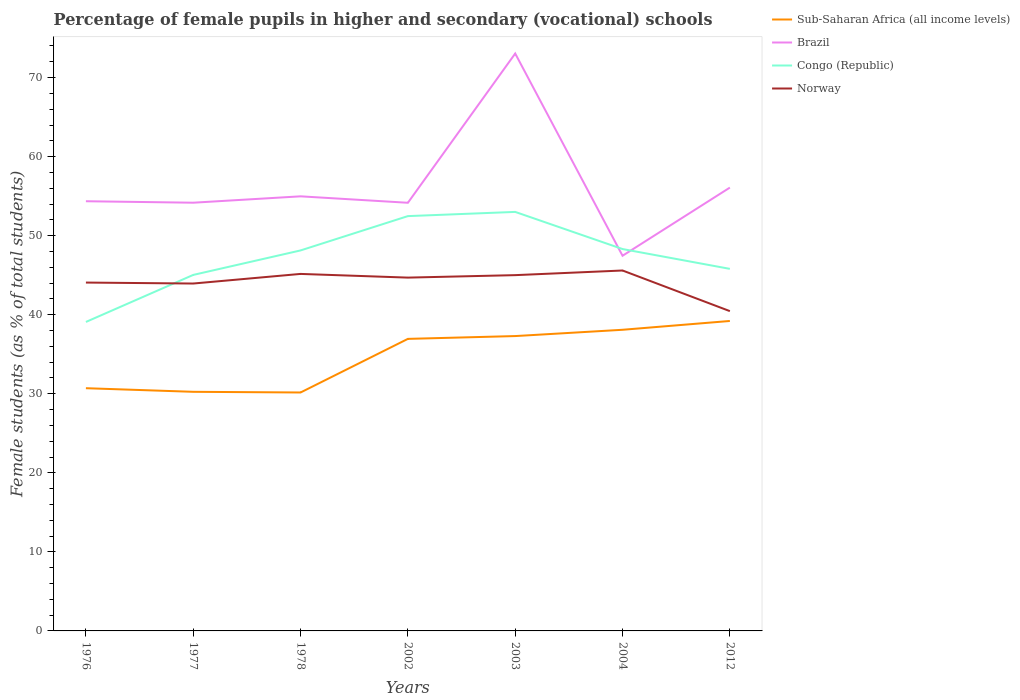Does the line corresponding to Norway intersect with the line corresponding to Congo (Republic)?
Provide a short and direct response. Yes. Is the number of lines equal to the number of legend labels?
Give a very brief answer. Yes. Across all years, what is the maximum percentage of female pupils in higher and secondary schools in Sub-Saharan Africa (all income levels)?
Give a very brief answer. 30.16. In which year was the percentage of female pupils in higher and secondary schools in Brazil maximum?
Your response must be concise. 2004. What is the total percentage of female pupils in higher and secondary schools in Congo (Republic) in the graph?
Give a very brief answer. -4.34. What is the difference between the highest and the second highest percentage of female pupils in higher and secondary schools in Norway?
Provide a short and direct response. 5.14. Is the percentage of female pupils in higher and secondary schools in Norway strictly greater than the percentage of female pupils in higher and secondary schools in Brazil over the years?
Ensure brevity in your answer.  Yes. What is the difference between two consecutive major ticks on the Y-axis?
Provide a short and direct response. 10. Does the graph contain any zero values?
Provide a succinct answer. No. Where does the legend appear in the graph?
Give a very brief answer. Top right. How many legend labels are there?
Offer a very short reply. 4. What is the title of the graph?
Provide a succinct answer. Percentage of female pupils in higher and secondary (vocational) schools. What is the label or title of the X-axis?
Make the answer very short. Years. What is the label or title of the Y-axis?
Offer a very short reply. Female students (as % of total students). What is the Female students (as % of total students) of Sub-Saharan Africa (all income levels) in 1976?
Provide a short and direct response. 30.7. What is the Female students (as % of total students) of Brazil in 1976?
Ensure brevity in your answer.  54.36. What is the Female students (as % of total students) of Congo (Republic) in 1976?
Give a very brief answer. 39.09. What is the Female students (as % of total students) of Norway in 1976?
Give a very brief answer. 44.07. What is the Female students (as % of total students) of Sub-Saharan Africa (all income levels) in 1977?
Ensure brevity in your answer.  30.25. What is the Female students (as % of total students) of Brazil in 1977?
Give a very brief answer. 54.17. What is the Female students (as % of total students) in Congo (Republic) in 1977?
Give a very brief answer. 45.04. What is the Female students (as % of total students) in Norway in 1977?
Your answer should be very brief. 43.95. What is the Female students (as % of total students) of Sub-Saharan Africa (all income levels) in 1978?
Keep it short and to the point. 30.16. What is the Female students (as % of total students) of Brazil in 1978?
Offer a very short reply. 54.98. What is the Female students (as % of total students) of Congo (Republic) in 1978?
Offer a terse response. 48.13. What is the Female students (as % of total students) in Norway in 1978?
Your answer should be compact. 45.16. What is the Female students (as % of total students) in Sub-Saharan Africa (all income levels) in 2002?
Ensure brevity in your answer.  36.94. What is the Female students (as % of total students) of Brazil in 2002?
Provide a short and direct response. 54.16. What is the Female students (as % of total students) of Congo (Republic) in 2002?
Make the answer very short. 52.48. What is the Female students (as % of total students) in Norway in 2002?
Your response must be concise. 44.7. What is the Female students (as % of total students) of Sub-Saharan Africa (all income levels) in 2003?
Offer a very short reply. 37.3. What is the Female students (as % of total students) in Brazil in 2003?
Your answer should be compact. 73.04. What is the Female students (as % of total students) of Congo (Republic) in 2003?
Your answer should be very brief. 53.01. What is the Female students (as % of total students) of Norway in 2003?
Give a very brief answer. 45.01. What is the Female students (as % of total students) in Sub-Saharan Africa (all income levels) in 2004?
Provide a short and direct response. 38.1. What is the Female students (as % of total students) of Brazil in 2004?
Keep it short and to the point. 47.46. What is the Female students (as % of total students) of Congo (Republic) in 2004?
Give a very brief answer. 48.31. What is the Female students (as % of total students) of Norway in 2004?
Provide a short and direct response. 45.6. What is the Female students (as % of total students) of Sub-Saharan Africa (all income levels) in 2012?
Make the answer very short. 39.21. What is the Female students (as % of total students) in Brazil in 2012?
Offer a terse response. 56.08. What is the Female students (as % of total students) of Congo (Republic) in 2012?
Provide a short and direct response. 45.8. What is the Female students (as % of total students) of Norway in 2012?
Give a very brief answer. 40.46. Across all years, what is the maximum Female students (as % of total students) in Sub-Saharan Africa (all income levels)?
Offer a very short reply. 39.21. Across all years, what is the maximum Female students (as % of total students) in Brazil?
Ensure brevity in your answer.  73.04. Across all years, what is the maximum Female students (as % of total students) in Congo (Republic)?
Give a very brief answer. 53.01. Across all years, what is the maximum Female students (as % of total students) in Norway?
Keep it short and to the point. 45.6. Across all years, what is the minimum Female students (as % of total students) of Sub-Saharan Africa (all income levels)?
Ensure brevity in your answer.  30.16. Across all years, what is the minimum Female students (as % of total students) of Brazil?
Ensure brevity in your answer.  47.46. Across all years, what is the minimum Female students (as % of total students) in Congo (Republic)?
Make the answer very short. 39.09. Across all years, what is the minimum Female students (as % of total students) in Norway?
Make the answer very short. 40.46. What is the total Female students (as % of total students) of Sub-Saharan Africa (all income levels) in the graph?
Offer a terse response. 242.67. What is the total Female students (as % of total students) in Brazil in the graph?
Keep it short and to the point. 394.26. What is the total Female students (as % of total students) in Congo (Republic) in the graph?
Your answer should be compact. 331.85. What is the total Female students (as % of total students) of Norway in the graph?
Your response must be concise. 308.93. What is the difference between the Female students (as % of total students) in Sub-Saharan Africa (all income levels) in 1976 and that in 1977?
Provide a short and direct response. 0.46. What is the difference between the Female students (as % of total students) in Brazil in 1976 and that in 1977?
Offer a terse response. 0.19. What is the difference between the Female students (as % of total students) in Congo (Republic) in 1976 and that in 1977?
Your answer should be compact. -5.95. What is the difference between the Female students (as % of total students) of Norway in 1976 and that in 1977?
Give a very brief answer. 0.12. What is the difference between the Female students (as % of total students) in Sub-Saharan Africa (all income levels) in 1976 and that in 1978?
Provide a short and direct response. 0.54. What is the difference between the Female students (as % of total students) in Brazil in 1976 and that in 1978?
Your answer should be compact. -0.62. What is the difference between the Female students (as % of total students) of Congo (Republic) in 1976 and that in 1978?
Ensure brevity in your answer.  -9.05. What is the difference between the Female students (as % of total students) in Norway in 1976 and that in 1978?
Your answer should be compact. -1.09. What is the difference between the Female students (as % of total students) in Sub-Saharan Africa (all income levels) in 1976 and that in 2002?
Your answer should be compact. -6.24. What is the difference between the Female students (as % of total students) in Brazil in 1976 and that in 2002?
Provide a short and direct response. 0.19. What is the difference between the Female students (as % of total students) of Congo (Republic) in 1976 and that in 2002?
Your answer should be compact. -13.39. What is the difference between the Female students (as % of total students) of Norway in 1976 and that in 2002?
Provide a succinct answer. -0.63. What is the difference between the Female students (as % of total students) of Sub-Saharan Africa (all income levels) in 1976 and that in 2003?
Offer a terse response. -6.6. What is the difference between the Female students (as % of total students) in Brazil in 1976 and that in 2003?
Ensure brevity in your answer.  -18.69. What is the difference between the Female students (as % of total students) in Congo (Republic) in 1976 and that in 2003?
Ensure brevity in your answer.  -13.92. What is the difference between the Female students (as % of total students) of Norway in 1976 and that in 2003?
Your answer should be very brief. -0.94. What is the difference between the Female students (as % of total students) of Sub-Saharan Africa (all income levels) in 1976 and that in 2004?
Your answer should be very brief. -7.39. What is the difference between the Female students (as % of total students) of Brazil in 1976 and that in 2004?
Provide a short and direct response. 6.9. What is the difference between the Female students (as % of total students) in Congo (Republic) in 1976 and that in 2004?
Keep it short and to the point. -9.22. What is the difference between the Female students (as % of total students) of Norway in 1976 and that in 2004?
Ensure brevity in your answer.  -1.53. What is the difference between the Female students (as % of total students) of Sub-Saharan Africa (all income levels) in 1976 and that in 2012?
Offer a terse response. -8.51. What is the difference between the Female students (as % of total students) in Brazil in 1976 and that in 2012?
Keep it short and to the point. -1.73. What is the difference between the Female students (as % of total students) of Congo (Republic) in 1976 and that in 2012?
Provide a short and direct response. -6.72. What is the difference between the Female students (as % of total students) of Norway in 1976 and that in 2012?
Your answer should be very brief. 3.61. What is the difference between the Female students (as % of total students) in Sub-Saharan Africa (all income levels) in 1977 and that in 1978?
Make the answer very short. 0.09. What is the difference between the Female students (as % of total students) of Brazil in 1977 and that in 1978?
Provide a short and direct response. -0.81. What is the difference between the Female students (as % of total students) of Congo (Republic) in 1977 and that in 1978?
Give a very brief answer. -3.1. What is the difference between the Female students (as % of total students) of Norway in 1977 and that in 1978?
Offer a very short reply. -1.22. What is the difference between the Female students (as % of total students) of Sub-Saharan Africa (all income levels) in 1977 and that in 2002?
Provide a succinct answer. -6.7. What is the difference between the Female students (as % of total students) in Brazil in 1977 and that in 2002?
Make the answer very short. 0.01. What is the difference between the Female students (as % of total students) in Congo (Republic) in 1977 and that in 2002?
Your response must be concise. -7.44. What is the difference between the Female students (as % of total students) in Norway in 1977 and that in 2002?
Your answer should be compact. -0.75. What is the difference between the Female students (as % of total students) in Sub-Saharan Africa (all income levels) in 1977 and that in 2003?
Provide a succinct answer. -7.05. What is the difference between the Female students (as % of total students) of Brazil in 1977 and that in 2003?
Provide a succinct answer. -18.87. What is the difference between the Female students (as % of total students) of Congo (Republic) in 1977 and that in 2003?
Your answer should be very brief. -7.97. What is the difference between the Female students (as % of total students) of Norway in 1977 and that in 2003?
Make the answer very short. -1.06. What is the difference between the Female students (as % of total students) of Sub-Saharan Africa (all income levels) in 1977 and that in 2004?
Your answer should be very brief. -7.85. What is the difference between the Female students (as % of total students) in Brazil in 1977 and that in 2004?
Your response must be concise. 6.71. What is the difference between the Female students (as % of total students) of Congo (Republic) in 1977 and that in 2004?
Make the answer very short. -3.27. What is the difference between the Female students (as % of total students) of Norway in 1977 and that in 2004?
Provide a succinct answer. -1.65. What is the difference between the Female students (as % of total students) in Sub-Saharan Africa (all income levels) in 1977 and that in 2012?
Provide a succinct answer. -8.96. What is the difference between the Female students (as % of total students) in Brazil in 1977 and that in 2012?
Offer a terse response. -1.91. What is the difference between the Female students (as % of total students) of Congo (Republic) in 1977 and that in 2012?
Ensure brevity in your answer.  -0.77. What is the difference between the Female students (as % of total students) in Norway in 1977 and that in 2012?
Make the answer very short. 3.49. What is the difference between the Female students (as % of total students) in Sub-Saharan Africa (all income levels) in 1978 and that in 2002?
Offer a very short reply. -6.78. What is the difference between the Female students (as % of total students) of Brazil in 1978 and that in 2002?
Provide a succinct answer. 0.82. What is the difference between the Female students (as % of total students) in Congo (Republic) in 1978 and that in 2002?
Your answer should be compact. -4.34. What is the difference between the Female students (as % of total students) of Norway in 1978 and that in 2002?
Your response must be concise. 0.47. What is the difference between the Female students (as % of total students) of Sub-Saharan Africa (all income levels) in 1978 and that in 2003?
Provide a succinct answer. -7.14. What is the difference between the Female students (as % of total students) in Brazil in 1978 and that in 2003?
Offer a very short reply. -18.07. What is the difference between the Female students (as % of total students) in Congo (Republic) in 1978 and that in 2003?
Offer a terse response. -4.87. What is the difference between the Female students (as % of total students) of Norway in 1978 and that in 2003?
Keep it short and to the point. 0.16. What is the difference between the Female students (as % of total students) of Sub-Saharan Africa (all income levels) in 1978 and that in 2004?
Keep it short and to the point. -7.93. What is the difference between the Female students (as % of total students) of Brazil in 1978 and that in 2004?
Provide a short and direct response. 7.52. What is the difference between the Female students (as % of total students) in Congo (Republic) in 1978 and that in 2004?
Make the answer very short. -0.17. What is the difference between the Female students (as % of total students) of Norway in 1978 and that in 2004?
Give a very brief answer. -0.43. What is the difference between the Female students (as % of total students) of Sub-Saharan Africa (all income levels) in 1978 and that in 2012?
Your answer should be very brief. -9.05. What is the difference between the Female students (as % of total students) in Brazil in 1978 and that in 2012?
Make the answer very short. -1.11. What is the difference between the Female students (as % of total students) of Congo (Republic) in 1978 and that in 2012?
Your response must be concise. 2.33. What is the difference between the Female students (as % of total students) of Norway in 1978 and that in 2012?
Provide a succinct answer. 4.71. What is the difference between the Female students (as % of total students) in Sub-Saharan Africa (all income levels) in 2002 and that in 2003?
Offer a very short reply. -0.36. What is the difference between the Female students (as % of total students) of Brazil in 2002 and that in 2003?
Make the answer very short. -18.88. What is the difference between the Female students (as % of total students) in Congo (Republic) in 2002 and that in 2003?
Make the answer very short. -0.53. What is the difference between the Female students (as % of total students) of Norway in 2002 and that in 2003?
Your answer should be compact. -0.31. What is the difference between the Female students (as % of total students) in Sub-Saharan Africa (all income levels) in 2002 and that in 2004?
Keep it short and to the point. -1.15. What is the difference between the Female students (as % of total students) in Brazil in 2002 and that in 2004?
Make the answer very short. 6.7. What is the difference between the Female students (as % of total students) in Congo (Republic) in 2002 and that in 2004?
Provide a short and direct response. 4.17. What is the difference between the Female students (as % of total students) of Norway in 2002 and that in 2004?
Ensure brevity in your answer.  -0.9. What is the difference between the Female students (as % of total students) in Sub-Saharan Africa (all income levels) in 2002 and that in 2012?
Your answer should be compact. -2.27. What is the difference between the Female students (as % of total students) of Brazil in 2002 and that in 2012?
Offer a very short reply. -1.92. What is the difference between the Female students (as % of total students) in Congo (Republic) in 2002 and that in 2012?
Offer a terse response. 6.67. What is the difference between the Female students (as % of total students) in Norway in 2002 and that in 2012?
Provide a short and direct response. 4.24. What is the difference between the Female students (as % of total students) in Sub-Saharan Africa (all income levels) in 2003 and that in 2004?
Provide a succinct answer. -0.8. What is the difference between the Female students (as % of total students) of Brazil in 2003 and that in 2004?
Your response must be concise. 25.58. What is the difference between the Female students (as % of total students) in Congo (Republic) in 2003 and that in 2004?
Provide a succinct answer. 4.7. What is the difference between the Female students (as % of total students) in Norway in 2003 and that in 2004?
Your response must be concise. -0.59. What is the difference between the Female students (as % of total students) of Sub-Saharan Africa (all income levels) in 2003 and that in 2012?
Ensure brevity in your answer.  -1.91. What is the difference between the Female students (as % of total students) of Brazil in 2003 and that in 2012?
Ensure brevity in your answer.  16.96. What is the difference between the Female students (as % of total students) in Congo (Republic) in 2003 and that in 2012?
Make the answer very short. 7.2. What is the difference between the Female students (as % of total students) in Norway in 2003 and that in 2012?
Your answer should be compact. 4.55. What is the difference between the Female students (as % of total students) of Sub-Saharan Africa (all income levels) in 2004 and that in 2012?
Your answer should be very brief. -1.12. What is the difference between the Female students (as % of total students) of Brazil in 2004 and that in 2012?
Provide a succinct answer. -8.62. What is the difference between the Female students (as % of total students) of Congo (Republic) in 2004 and that in 2012?
Make the answer very short. 2.51. What is the difference between the Female students (as % of total students) of Norway in 2004 and that in 2012?
Provide a succinct answer. 5.14. What is the difference between the Female students (as % of total students) in Sub-Saharan Africa (all income levels) in 1976 and the Female students (as % of total students) in Brazil in 1977?
Provide a short and direct response. -23.47. What is the difference between the Female students (as % of total students) in Sub-Saharan Africa (all income levels) in 1976 and the Female students (as % of total students) in Congo (Republic) in 1977?
Give a very brief answer. -14.33. What is the difference between the Female students (as % of total students) in Sub-Saharan Africa (all income levels) in 1976 and the Female students (as % of total students) in Norway in 1977?
Make the answer very short. -13.24. What is the difference between the Female students (as % of total students) of Brazil in 1976 and the Female students (as % of total students) of Congo (Republic) in 1977?
Keep it short and to the point. 9.32. What is the difference between the Female students (as % of total students) in Brazil in 1976 and the Female students (as % of total students) in Norway in 1977?
Provide a short and direct response. 10.41. What is the difference between the Female students (as % of total students) in Congo (Republic) in 1976 and the Female students (as % of total students) in Norway in 1977?
Your answer should be compact. -4.86. What is the difference between the Female students (as % of total students) in Sub-Saharan Africa (all income levels) in 1976 and the Female students (as % of total students) in Brazil in 1978?
Make the answer very short. -24.27. What is the difference between the Female students (as % of total students) of Sub-Saharan Africa (all income levels) in 1976 and the Female students (as % of total students) of Congo (Republic) in 1978?
Ensure brevity in your answer.  -17.43. What is the difference between the Female students (as % of total students) in Sub-Saharan Africa (all income levels) in 1976 and the Female students (as % of total students) in Norway in 1978?
Your answer should be very brief. -14.46. What is the difference between the Female students (as % of total students) in Brazil in 1976 and the Female students (as % of total students) in Congo (Republic) in 1978?
Make the answer very short. 6.22. What is the difference between the Female students (as % of total students) in Brazil in 1976 and the Female students (as % of total students) in Norway in 1978?
Keep it short and to the point. 9.19. What is the difference between the Female students (as % of total students) in Congo (Republic) in 1976 and the Female students (as % of total students) in Norway in 1978?
Give a very brief answer. -6.08. What is the difference between the Female students (as % of total students) in Sub-Saharan Africa (all income levels) in 1976 and the Female students (as % of total students) in Brazil in 2002?
Give a very brief answer. -23.46. What is the difference between the Female students (as % of total students) of Sub-Saharan Africa (all income levels) in 1976 and the Female students (as % of total students) of Congo (Republic) in 2002?
Your answer should be compact. -21.77. What is the difference between the Female students (as % of total students) in Sub-Saharan Africa (all income levels) in 1976 and the Female students (as % of total students) in Norway in 2002?
Ensure brevity in your answer.  -13.99. What is the difference between the Female students (as % of total students) in Brazil in 1976 and the Female students (as % of total students) in Congo (Republic) in 2002?
Keep it short and to the point. 1.88. What is the difference between the Female students (as % of total students) of Brazil in 1976 and the Female students (as % of total students) of Norway in 2002?
Provide a short and direct response. 9.66. What is the difference between the Female students (as % of total students) in Congo (Republic) in 1976 and the Female students (as % of total students) in Norway in 2002?
Offer a very short reply. -5.61. What is the difference between the Female students (as % of total students) of Sub-Saharan Africa (all income levels) in 1976 and the Female students (as % of total students) of Brazil in 2003?
Offer a terse response. -42.34. What is the difference between the Female students (as % of total students) of Sub-Saharan Africa (all income levels) in 1976 and the Female students (as % of total students) of Congo (Republic) in 2003?
Ensure brevity in your answer.  -22.3. What is the difference between the Female students (as % of total students) in Sub-Saharan Africa (all income levels) in 1976 and the Female students (as % of total students) in Norway in 2003?
Offer a very short reply. -14.3. What is the difference between the Female students (as % of total students) in Brazil in 1976 and the Female students (as % of total students) in Congo (Republic) in 2003?
Your response must be concise. 1.35. What is the difference between the Female students (as % of total students) in Brazil in 1976 and the Female students (as % of total students) in Norway in 2003?
Keep it short and to the point. 9.35. What is the difference between the Female students (as % of total students) in Congo (Republic) in 1976 and the Female students (as % of total students) in Norway in 2003?
Your answer should be very brief. -5.92. What is the difference between the Female students (as % of total students) in Sub-Saharan Africa (all income levels) in 1976 and the Female students (as % of total students) in Brazil in 2004?
Ensure brevity in your answer.  -16.76. What is the difference between the Female students (as % of total students) of Sub-Saharan Africa (all income levels) in 1976 and the Female students (as % of total students) of Congo (Republic) in 2004?
Offer a terse response. -17.6. What is the difference between the Female students (as % of total students) of Sub-Saharan Africa (all income levels) in 1976 and the Female students (as % of total students) of Norway in 2004?
Give a very brief answer. -14.89. What is the difference between the Female students (as % of total students) of Brazil in 1976 and the Female students (as % of total students) of Congo (Republic) in 2004?
Provide a succinct answer. 6.05. What is the difference between the Female students (as % of total students) in Brazil in 1976 and the Female students (as % of total students) in Norway in 2004?
Your response must be concise. 8.76. What is the difference between the Female students (as % of total students) of Congo (Republic) in 1976 and the Female students (as % of total students) of Norway in 2004?
Your answer should be compact. -6.51. What is the difference between the Female students (as % of total students) of Sub-Saharan Africa (all income levels) in 1976 and the Female students (as % of total students) of Brazil in 2012?
Offer a terse response. -25.38. What is the difference between the Female students (as % of total students) in Sub-Saharan Africa (all income levels) in 1976 and the Female students (as % of total students) in Congo (Republic) in 2012?
Offer a terse response. -15.1. What is the difference between the Female students (as % of total students) of Sub-Saharan Africa (all income levels) in 1976 and the Female students (as % of total students) of Norway in 2012?
Provide a short and direct response. -9.75. What is the difference between the Female students (as % of total students) in Brazil in 1976 and the Female students (as % of total students) in Congo (Republic) in 2012?
Provide a succinct answer. 8.55. What is the difference between the Female students (as % of total students) of Brazil in 1976 and the Female students (as % of total students) of Norway in 2012?
Your answer should be very brief. 13.9. What is the difference between the Female students (as % of total students) in Congo (Republic) in 1976 and the Female students (as % of total students) in Norway in 2012?
Make the answer very short. -1.37. What is the difference between the Female students (as % of total students) in Sub-Saharan Africa (all income levels) in 1977 and the Female students (as % of total students) in Brazil in 1978?
Ensure brevity in your answer.  -24.73. What is the difference between the Female students (as % of total students) of Sub-Saharan Africa (all income levels) in 1977 and the Female students (as % of total students) of Congo (Republic) in 1978?
Make the answer very short. -17.89. What is the difference between the Female students (as % of total students) of Sub-Saharan Africa (all income levels) in 1977 and the Female students (as % of total students) of Norway in 1978?
Offer a terse response. -14.91. What is the difference between the Female students (as % of total students) in Brazil in 1977 and the Female students (as % of total students) in Congo (Republic) in 1978?
Offer a very short reply. 6.04. What is the difference between the Female students (as % of total students) of Brazil in 1977 and the Female students (as % of total students) of Norway in 1978?
Provide a short and direct response. 9.01. What is the difference between the Female students (as % of total students) in Congo (Republic) in 1977 and the Female students (as % of total students) in Norway in 1978?
Ensure brevity in your answer.  -0.13. What is the difference between the Female students (as % of total students) in Sub-Saharan Africa (all income levels) in 1977 and the Female students (as % of total students) in Brazil in 2002?
Keep it short and to the point. -23.91. What is the difference between the Female students (as % of total students) in Sub-Saharan Africa (all income levels) in 1977 and the Female students (as % of total students) in Congo (Republic) in 2002?
Keep it short and to the point. -22.23. What is the difference between the Female students (as % of total students) of Sub-Saharan Africa (all income levels) in 1977 and the Female students (as % of total students) of Norway in 2002?
Ensure brevity in your answer.  -14.45. What is the difference between the Female students (as % of total students) in Brazil in 1977 and the Female students (as % of total students) in Congo (Republic) in 2002?
Your answer should be compact. 1.7. What is the difference between the Female students (as % of total students) of Brazil in 1977 and the Female students (as % of total students) of Norway in 2002?
Provide a succinct answer. 9.48. What is the difference between the Female students (as % of total students) in Congo (Republic) in 1977 and the Female students (as % of total students) in Norway in 2002?
Your response must be concise. 0.34. What is the difference between the Female students (as % of total students) of Sub-Saharan Africa (all income levels) in 1977 and the Female students (as % of total students) of Brazil in 2003?
Provide a short and direct response. -42.8. What is the difference between the Female students (as % of total students) in Sub-Saharan Africa (all income levels) in 1977 and the Female students (as % of total students) in Congo (Republic) in 2003?
Give a very brief answer. -22.76. What is the difference between the Female students (as % of total students) in Sub-Saharan Africa (all income levels) in 1977 and the Female students (as % of total students) in Norway in 2003?
Your answer should be compact. -14.76. What is the difference between the Female students (as % of total students) of Brazil in 1977 and the Female students (as % of total students) of Congo (Republic) in 2003?
Your answer should be compact. 1.17. What is the difference between the Female students (as % of total students) in Brazil in 1977 and the Female students (as % of total students) in Norway in 2003?
Keep it short and to the point. 9.16. What is the difference between the Female students (as % of total students) of Congo (Republic) in 1977 and the Female students (as % of total students) of Norway in 2003?
Keep it short and to the point. 0.03. What is the difference between the Female students (as % of total students) in Sub-Saharan Africa (all income levels) in 1977 and the Female students (as % of total students) in Brazil in 2004?
Your response must be concise. -17.21. What is the difference between the Female students (as % of total students) of Sub-Saharan Africa (all income levels) in 1977 and the Female students (as % of total students) of Congo (Republic) in 2004?
Offer a terse response. -18.06. What is the difference between the Female students (as % of total students) of Sub-Saharan Africa (all income levels) in 1977 and the Female students (as % of total students) of Norway in 2004?
Your answer should be very brief. -15.35. What is the difference between the Female students (as % of total students) of Brazil in 1977 and the Female students (as % of total students) of Congo (Republic) in 2004?
Give a very brief answer. 5.86. What is the difference between the Female students (as % of total students) of Brazil in 1977 and the Female students (as % of total students) of Norway in 2004?
Your answer should be compact. 8.58. What is the difference between the Female students (as % of total students) in Congo (Republic) in 1977 and the Female students (as % of total students) in Norway in 2004?
Offer a very short reply. -0.56. What is the difference between the Female students (as % of total students) of Sub-Saharan Africa (all income levels) in 1977 and the Female students (as % of total students) of Brazil in 2012?
Your response must be concise. -25.84. What is the difference between the Female students (as % of total students) of Sub-Saharan Africa (all income levels) in 1977 and the Female students (as % of total students) of Congo (Republic) in 2012?
Your answer should be very brief. -15.56. What is the difference between the Female students (as % of total students) in Sub-Saharan Africa (all income levels) in 1977 and the Female students (as % of total students) in Norway in 2012?
Give a very brief answer. -10.21. What is the difference between the Female students (as % of total students) of Brazil in 1977 and the Female students (as % of total students) of Congo (Republic) in 2012?
Give a very brief answer. 8.37. What is the difference between the Female students (as % of total students) of Brazil in 1977 and the Female students (as % of total students) of Norway in 2012?
Provide a succinct answer. 13.72. What is the difference between the Female students (as % of total students) in Congo (Republic) in 1977 and the Female students (as % of total students) in Norway in 2012?
Offer a very short reply. 4.58. What is the difference between the Female students (as % of total students) of Sub-Saharan Africa (all income levels) in 1978 and the Female students (as % of total students) of Brazil in 2002?
Give a very brief answer. -24. What is the difference between the Female students (as % of total students) in Sub-Saharan Africa (all income levels) in 1978 and the Female students (as % of total students) in Congo (Republic) in 2002?
Your answer should be very brief. -22.31. What is the difference between the Female students (as % of total students) of Sub-Saharan Africa (all income levels) in 1978 and the Female students (as % of total students) of Norway in 2002?
Offer a very short reply. -14.53. What is the difference between the Female students (as % of total students) in Brazil in 1978 and the Female students (as % of total students) in Congo (Republic) in 2002?
Give a very brief answer. 2.5. What is the difference between the Female students (as % of total students) of Brazil in 1978 and the Female students (as % of total students) of Norway in 2002?
Your answer should be very brief. 10.28. What is the difference between the Female students (as % of total students) in Congo (Republic) in 1978 and the Female students (as % of total students) in Norway in 2002?
Give a very brief answer. 3.44. What is the difference between the Female students (as % of total students) in Sub-Saharan Africa (all income levels) in 1978 and the Female students (as % of total students) in Brazil in 2003?
Keep it short and to the point. -42.88. What is the difference between the Female students (as % of total students) of Sub-Saharan Africa (all income levels) in 1978 and the Female students (as % of total students) of Congo (Republic) in 2003?
Make the answer very short. -22.84. What is the difference between the Female students (as % of total students) in Sub-Saharan Africa (all income levels) in 1978 and the Female students (as % of total students) in Norway in 2003?
Offer a very short reply. -14.84. What is the difference between the Female students (as % of total students) in Brazil in 1978 and the Female students (as % of total students) in Congo (Republic) in 2003?
Give a very brief answer. 1.97. What is the difference between the Female students (as % of total students) of Brazil in 1978 and the Female students (as % of total students) of Norway in 2003?
Provide a succinct answer. 9.97. What is the difference between the Female students (as % of total students) in Congo (Republic) in 1978 and the Female students (as % of total students) in Norway in 2003?
Your answer should be compact. 3.13. What is the difference between the Female students (as % of total students) of Sub-Saharan Africa (all income levels) in 1978 and the Female students (as % of total students) of Brazil in 2004?
Offer a very short reply. -17.3. What is the difference between the Female students (as % of total students) in Sub-Saharan Africa (all income levels) in 1978 and the Female students (as % of total students) in Congo (Republic) in 2004?
Keep it short and to the point. -18.15. What is the difference between the Female students (as % of total students) in Sub-Saharan Africa (all income levels) in 1978 and the Female students (as % of total students) in Norway in 2004?
Your answer should be very brief. -15.43. What is the difference between the Female students (as % of total students) in Brazil in 1978 and the Female students (as % of total students) in Congo (Republic) in 2004?
Offer a terse response. 6.67. What is the difference between the Female students (as % of total students) in Brazil in 1978 and the Female students (as % of total students) in Norway in 2004?
Make the answer very short. 9.38. What is the difference between the Female students (as % of total students) of Congo (Republic) in 1978 and the Female students (as % of total students) of Norway in 2004?
Provide a short and direct response. 2.54. What is the difference between the Female students (as % of total students) in Sub-Saharan Africa (all income levels) in 1978 and the Female students (as % of total students) in Brazil in 2012?
Ensure brevity in your answer.  -25.92. What is the difference between the Female students (as % of total students) of Sub-Saharan Africa (all income levels) in 1978 and the Female students (as % of total students) of Congo (Republic) in 2012?
Your response must be concise. -15.64. What is the difference between the Female students (as % of total students) in Sub-Saharan Africa (all income levels) in 1978 and the Female students (as % of total students) in Norway in 2012?
Your answer should be compact. -10.29. What is the difference between the Female students (as % of total students) of Brazil in 1978 and the Female students (as % of total students) of Congo (Republic) in 2012?
Your answer should be compact. 9.17. What is the difference between the Female students (as % of total students) in Brazil in 1978 and the Female students (as % of total students) in Norway in 2012?
Your response must be concise. 14.52. What is the difference between the Female students (as % of total students) in Congo (Republic) in 1978 and the Female students (as % of total students) in Norway in 2012?
Your response must be concise. 7.68. What is the difference between the Female students (as % of total students) of Sub-Saharan Africa (all income levels) in 2002 and the Female students (as % of total students) of Brazil in 2003?
Provide a succinct answer. -36.1. What is the difference between the Female students (as % of total students) in Sub-Saharan Africa (all income levels) in 2002 and the Female students (as % of total students) in Congo (Republic) in 2003?
Give a very brief answer. -16.06. What is the difference between the Female students (as % of total students) of Sub-Saharan Africa (all income levels) in 2002 and the Female students (as % of total students) of Norway in 2003?
Provide a succinct answer. -8.06. What is the difference between the Female students (as % of total students) of Brazil in 2002 and the Female students (as % of total students) of Congo (Republic) in 2003?
Your answer should be compact. 1.16. What is the difference between the Female students (as % of total students) in Brazil in 2002 and the Female students (as % of total students) in Norway in 2003?
Offer a terse response. 9.16. What is the difference between the Female students (as % of total students) of Congo (Republic) in 2002 and the Female students (as % of total students) of Norway in 2003?
Your answer should be very brief. 7.47. What is the difference between the Female students (as % of total students) of Sub-Saharan Africa (all income levels) in 2002 and the Female students (as % of total students) of Brazil in 2004?
Provide a short and direct response. -10.52. What is the difference between the Female students (as % of total students) of Sub-Saharan Africa (all income levels) in 2002 and the Female students (as % of total students) of Congo (Republic) in 2004?
Your answer should be compact. -11.36. What is the difference between the Female students (as % of total students) of Sub-Saharan Africa (all income levels) in 2002 and the Female students (as % of total students) of Norway in 2004?
Make the answer very short. -8.65. What is the difference between the Female students (as % of total students) in Brazil in 2002 and the Female students (as % of total students) in Congo (Republic) in 2004?
Your response must be concise. 5.85. What is the difference between the Female students (as % of total students) in Brazil in 2002 and the Female students (as % of total students) in Norway in 2004?
Give a very brief answer. 8.57. What is the difference between the Female students (as % of total students) in Congo (Republic) in 2002 and the Female students (as % of total students) in Norway in 2004?
Offer a very short reply. 6.88. What is the difference between the Female students (as % of total students) of Sub-Saharan Africa (all income levels) in 2002 and the Female students (as % of total students) of Brazil in 2012?
Offer a very short reply. -19.14. What is the difference between the Female students (as % of total students) in Sub-Saharan Africa (all income levels) in 2002 and the Female students (as % of total students) in Congo (Republic) in 2012?
Keep it short and to the point. -8.86. What is the difference between the Female students (as % of total students) of Sub-Saharan Africa (all income levels) in 2002 and the Female students (as % of total students) of Norway in 2012?
Give a very brief answer. -3.51. What is the difference between the Female students (as % of total students) of Brazil in 2002 and the Female students (as % of total students) of Congo (Republic) in 2012?
Your answer should be compact. 8.36. What is the difference between the Female students (as % of total students) of Brazil in 2002 and the Female students (as % of total students) of Norway in 2012?
Offer a terse response. 13.71. What is the difference between the Female students (as % of total students) of Congo (Republic) in 2002 and the Female students (as % of total students) of Norway in 2012?
Offer a very short reply. 12.02. What is the difference between the Female students (as % of total students) of Sub-Saharan Africa (all income levels) in 2003 and the Female students (as % of total students) of Brazil in 2004?
Your answer should be compact. -10.16. What is the difference between the Female students (as % of total students) in Sub-Saharan Africa (all income levels) in 2003 and the Female students (as % of total students) in Congo (Republic) in 2004?
Ensure brevity in your answer.  -11.01. What is the difference between the Female students (as % of total students) of Sub-Saharan Africa (all income levels) in 2003 and the Female students (as % of total students) of Norway in 2004?
Your response must be concise. -8.3. What is the difference between the Female students (as % of total students) of Brazil in 2003 and the Female students (as % of total students) of Congo (Republic) in 2004?
Give a very brief answer. 24.73. What is the difference between the Female students (as % of total students) of Brazil in 2003 and the Female students (as % of total students) of Norway in 2004?
Keep it short and to the point. 27.45. What is the difference between the Female students (as % of total students) of Congo (Republic) in 2003 and the Female students (as % of total students) of Norway in 2004?
Your answer should be very brief. 7.41. What is the difference between the Female students (as % of total students) in Sub-Saharan Africa (all income levels) in 2003 and the Female students (as % of total students) in Brazil in 2012?
Ensure brevity in your answer.  -18.78. What is the difference between the Female students (as % of total students) of Sub-Saharan Africa (all income levels) in 2003 and the Female students (as % of total students) of Congo (Republic) in 2012?
Give a very brief answer. -8.5. What is the difference between the Female students (as % of total students) of Sub-Saharan Africa (all income levels) in 2003 and the Female students (as % of total students) of Norway in 2012?
Provide a succinct answer. -3.16. What is the difference between the Female students (as % of total students) in Brazil in 2003 and the Female students (as % of total students) in Congo (Republic) in 2012?
Keep it short and to the point. 27.24. What is the difference between the Female students (as % of total students) of Brazil in 2003 and the Female students (as % of total students) of Norway in 2012?
Offer a very short reply. 32.59. What is the difference between the Female students (as % of total students) in Congo (Republic) in 2003 and the Female students (as % of total students) in Norway in 2012?
Offer a terse response. 12.55. What is the difference between the Female students (as % of total students) of Sub-Saharan Africa (all income levels) in 2004 and the Female students (as % of total students) of Brazil in 2012?
Make the answer very short. -17.99. What is the difference between the Female students (as % of total students) in Sub-Saharan Africa (all income levels) in 2004 and the Female students (as % of total students) in Congo (Republic) in 2012?
Offer a terse response. -7.71. What is the difference between the Female students (as % of total students) in Sub-Saharan Africa (all income levels) in 2004 and the Female students (as % of total students) in Norway in 2012?
Your answer should be very brief. -2.36. What is the difference between the Female students (as % of total students) in Brazil in 2004 and the Female students (as % of total students) in Congo (Republic) in 2012?
Give a very brief answer. 1.66. What is the difference between the Female students (as % of total students) in Brazil in 2004 and the Female students (as % of total students) in Norway in 2012?
Your answer should be compact. 7. What is the difference between the Female students (as % of total students) of Congo (Republic) in 2004 and the Female students (as % of total students) of Norway in 2012?
Your answer should be very brief. 7.85. What is the average Female students (as % of total students) of Sub-Saharan Africa (all income levels) per year?
Your answer should be compact. 34.67. What is the average Female students (as % of total students) in Brazil per year?
Your response must be concise. 56.32. What is the average Female students (as % of total students) in Congo (Republic) per year?
Offer a very short reply. 47.41. What is the average Female students (as % of total students) of Norway per year?
Your answer should be very brief. 44.13. In the year 1976, what is the difference between the Female students (as % of total students) of Sub-Saharan Africa (all income levels) and Female students (as % of total students) of Brazil?
Your response must be concise. -23.65. In the year 1976, what is the difference between the Female students (as % of total students) of Sub-Saharan Africa (all income levels) and Female students (as % of total students) of Congo (Republic)?
Provide a succinct answer. -8.38. In the year 1976, what is the difference between the Female students (as % of total students) in Sub-Saharan Africa (all income levels) and Female students (as % of total students) in Norway?
Keep it short and to the point. -13.36. In the year 1976, what is the difference between the Female students (as % of total students) of Brazil and Female students (as % of total students) of Congo (Republic)?
Your response must be concise. 15.27. In the year 1976, what is the difference between the Female students (as % of total students) of Brazil and Female students (as % of total students) of Norway?
Your answer should be compact. 10.29. In the year 1976, what is the difference between the Female students (as % of total students) in Congo (Republic) and Female students (as % of total students) in Norway?
Ensure brevity in your answer.  -4.98. In the year 1977, what is the difference between the Female students (as % of total students) of Sub-Saharan Africa (all income levels) and Female students (as % of total students) of Brazil?
Provide a short and direct response. -23.92. In the year 1977, what is the difference between the Female students (as % of total students) of Sub-Saharan Africa (all income levels) and Female students (as % of total students) of Congo (Republic)?
Ensure brevity in your answer.  -14.79. In the year 1977, what is the difference between the Female students (as % of total students) of Sub-Saharan Africa (all income levels) and Female students (as % of total students) of Norway?
Keep it short and to the point. -13.7. In the year 1977, what is the difference between the Female students (as % of total students) of Brazil and Female students (as % of total students) of Congo (Republic)?
Offer a terse response. 9.14. In the year 1977, what is the difference between the Female students (as % of total students) of Brazil and Female students (as % of total students) of Norway?
Your answer should be compact. 10.23. In the year 1977, what is the difference between the Female students (as % of total students) of Congo (Republic) and Female students (as % of total students) of Norway?
Provide a short and direct response. 1.09. In the year 1978, what is the difference between the Female students (as % of total students) of Sub-Saharan Africa (all income levels) and Female students (as % of total students) of Brazil?
Keep it short and to the point. -24.82. In the year 1978, what is the difference between the Female students (as % of total students) in Sub-Saharan Africa (all income levels) and Female students (as % of total students) in Congo (Republic)?
Make the answer very short. -17.97. In the year 1978, what is the difference between the Female students (as % of total students) of Sub-Saharan Africa (all income levels) and Female students (as % of total students) of Norway?
Offer a terse response. -15. In the year 1978, what is the difference between the Female students (as % of total students) in Brazil and Female students (as % of total students) in Congo (Republic)?
Provide a short and direct response. 6.84. In the year 1978, what is the difference between the Female students (as % of total students) of Brazil and Female students (as % of total students) of Norway?
Your answer should be compact. 9.82. In the year 1978, what is the difference between the Female students (as % of total students) of Congo (Republic) and Female students (as % of total students) of Norway?
Provide a short and direct response. 2.97. In the year 2002, what is the difference between the Female students (as % of total students) in Sub-Saharan Africa (all income levels) and Female students (as % of total students) in Brazil?
Offer a very short reply. -17.22. In the year 2002, what is the difference between the Female students (as % of total students) of Sub-Saharan Africa (all income levels) and Female students (as % of total students) of Congo (Republic)?
Offer a very short reply. -15.53. In the year 2002, what is the difference between the Female students (as % of total students) in Sub-Saharan Africa (all income levels) and Female students (as % of total students) in Norway?
Provide a succinct answer. -7.75. In the year 2002, what is the difference between the Female students (as % of total students) in Brazil and Female students (as % of total students) in Congo (Republic)?
Make the answer very short. 1.69. In the year 2002, what is the difference between the Female students (as % of total students) in Brazil and Female students (as % of total students) in Norway?
Your answer should be very brief. 9.47. In the year 2002, what is the difference between the Female students (as % of total students) in Congo (Republic) and Female students (as % of total students) in Norway?
Ensure brevity in your answer.  7.78. In the year 2003, what is the difference between the Female students (as % of total students) in Sub-Saharan Africa (all income levels) and Female students (as % of total students) in Brazil?
Offer a terse response. -35.74. In the year 2003, what is the difference between the Female students (as % of total students) in Sub-Saharan Africa (all income levels) and Female students (as % of total students) in Congo (Republic)?
Keep it short and to the point. -15.71. In the year 2003, what is the difference between the Female students (as % of total students) of Sub-Saharan Africa (all income levels) and Female students (as % of total students) of Norway?
Provide a succinct answer. -7.71. In the year 2003, what is the difference between the Female students (as % of total students) in Brazil and Female students (as % of total students) in Congo (Republic)?
Ensure brevity in your answer.  20.04. In the year 2003, what is the difference between the Female students (as % of total students) of Brazil and Female students (as % of total students) of Norway?
Your response must be concise. 28.04. In the year 2003, what is the difference between the Female students (as % of total students) of Congo (Republic) and Female students (as % of total students) of Norway?
Provide a short and direct response. 8. In the year 2004, what is the difference between the Female students (as % of total students) in Sub-Saharan Africa (all income levels) and Female students (as % of total students) in Brazil?
Your response must be concise. -9.36. In the year 2004, what is the difference between the Female students (as % of total students) of Sub-Saharan Africa (all income levels) and Female students (as % of total students) of Congo (Republic)?
Give a very brief answer. -10.21. In the year 2004, what is the difference between the Female students (as % of total students) in Sub-Saharan Africa (all income levels) and Female students (as % of total students) in Norway?
Provide a short and direct response. -7.5. In the year 2004, what is the difference between the Female students (as % of total students) in Brazil and Female students (as % of total students) in Congo (Republic)?
Ensure brevity in your answer.  -0.85. In the year 2004, what is the difference between the Female students (as % of total students) in Brazil and Female students (as % of total students) in Norway?
Make the answer very short. 1.86. In the year 2004, what is the difference between the Female students (as % of total students) of Congo (Republic) and Female students (as % of total students) of Norway?
Provide a short and direct response. 2.71. In the year 2012, what is the difference between the Female students (as % of total students) in Sub-Saharan Africa (all income levels) and Female students (as % of total students) in Brazil?
Keep it short and to the point. -16.87. In the year 2012, what is the difference between the Female students (as % of total students) in Sub-Saharan Africa (all income levels) and Female students (as % of total students) in Congo (Republic)?
Provide a succinct answer. -6.59. In the year 2012, what is the difference between the Female students (as % of total students) in Sub-Saharan Africa (all income levels) and Female students (as % of total students) in Norway?
Your response must be concise. -1.24. In the year 2012, what is the difference between the Female students (as % of total students) in Brazil and Female students (as % of total students) in Congo (Republic)?
Give a very brief answer. 10.28. In the year 2012, what is the difference between the Female students (as % of total students) of Brazil and Female students (as % of total students) of Norway?
Provide a short and direct response. 15.63. In the year 2012, what is the difference between the Female students (as % of total students) of Congo (Republic) and Female students (as % of total students) of Norway?
Offer a very short reply. 5.35. What is the ratio of the Female students (as % of total students) of Sub-Saharan Africa (all income levels) in 1976 to that in 1977?
Your answer should be very brief. 1.02. What is the ratio of the Female students (as % of total students) of Brazil in 1976 to that in 1977?
Offer a terse response. 1. What is the ratio of the Female students (as % of total students) of Congo (Republic) in 1976 to that in 1977?
Provide a short and direct response. 0.87. What is the ratio of the Female students (as % of total students) of Sub-Saharan Africa (all income levels) in 1976 to that in 1978?
Your response must be concise. 1.02. What is the ratio of the Female students (as % of total students) of Brazil in 1976 to that in 1978?
Ensure brevity in your answer.  0.99. What is the ratio of the Female students (as % of total students) in Congo (Republic) in 1976 to that in 1978?
Your response must be concise. 0.81. What is the ratio of the Female students (as % of total students) of Norway in 1976 to that in 1978?
Offer a terse response. 0.98. What is the ratio of the Female students (as % of total students) in Sub-Saharan Africa (all income levels) in 1976 to that in 2002?
Offer a very short reply. 0.83. What is the ratio of the Female students (as % of total students) of Congo (Republic) in 1976 to that in 2002?
Ensure brevity in your answer.  0.74. What is the ratio of the Female students (as % of total students) in Sub-Saharan Africa (all income levels) in 1976 to that in 2003?
Provide a short and direct response. 0.82. What is the ratio of the Female students (as % of total students) of Brazil in 1976 to that in 2003?
Your answer should be very brief. 0.74. What is the ratio of the Female students (as % of total students) of Congo (Republic) in 1976 to that in 2003?
Your answer should be very brief. 0.74. What is the ratio of the Female students (as % of total students) in Norway in 1976 to that in 2003?
Provide a succinct answer. 0.98. What is the ratio of the Female students (as % of total students) in Sub-Saharan Africa (all income levels) in 1976 to that in 2004?
Your answer should be compact. 0.81. What is the ratio of the Female students (as % of total students) in Brazil in 1976 to that in 2004?
Ensure brevity in your answer.  1.15. What is the ratio of the Female students (as % of total students) of Congo (Republic) in 1976 to that in 2004?
Provide a short and direct response. 0.81. What is the ratio of the Female students (as % of total students) in Norway in 1976 to that in 2004?
Make the answer very short. 0.97. What is the ratio of the Female students (as % of total students) of Sub-Saharan Africa (all income levels) in 1976 to that in 2012?
Your answer should be very brief. 0.78. What is the ratio of the Female students (as % of total students) in Brazil in 1976 to that in 2012?
Provide a short and direct response. 0.97. What is the ratio of the Female students (as % of total students) in Congo (Republic) in 1976 to that in 2012?
Your answer should be compact. 0.85. What is the ratio of the Female students (as % of total students) in Norway in 1976 to that in 2012?
Your answer should be very brief. 1.09. What is the ratio of the Female students (as % of total students) of Congo (Republic) in 1977 to that in 1978?
Offer a terse response. 0.94. What is the ratio of the Female students (as % of total students) of Norway in 1977 to that in 1978?
Your response must be concise. 0.97. What is the ratio of the Female students (as % of total students) in Sub-Saharan Africa (all income levels) in 1977 to that in 2002?
Keep it short and to the point. 0.82. What is the ratio of the Female students (as % of total students) of Brazil in 1977 to that in 2002?
Your response must be concise. 1. What is the ratio of the Female students (as % of total students) in Congo (Republic) in 1977 to that in 2002?
Give a very brief answer. 0.86. What is the ratio of the Female students (as % of total students) in Norway in 1977 to that in 2002?
Your answer should be very brief. 0.98. What is the ratio of the Female students (as % of total students) in Sub-Saharan Africa (all income levels) in 1977 to that in 2003?
Your answer should be very brief. 0.81. What is the ratio of the Female students (as % of total students) in Brazil in 1977 to that in 2003?
Your response must be concise. 0.74. What is the ratio of the Female students (as % of total students) of Congo (Republic) in 1977 to that in 2003?
Keep it short and to the point. 0.85. What is the ratio of the Female students (as % of total students) in Norway in 1977 to that in 2003?
Provide a succinct answer. 0.98. What is the ratio of the Female students (as % of total students) in Sub-Saharan Africa (all income levels) in 1977 to that in 2004?
Offer a terse response. 0.79. What is the ratio of the Female students (as % of total students) of Brazil in 1977 to that in 2004?
Keep it short and to the point. 1.14. What is the ratio of the Female students (as % of total students) in Congo (Republic) in 1977 to that in 2004?
Offer a terse response. 0.93. What is the ratio of the Female students (as % of total students) of Norway in 1977 to that in 2004?
Ensure brevity in your answer.  0.96. What is the ratio of the Female students (as % of total students) of Sub-Saharan Africa (all income levels) in 1977 to that in 2012?
Your answer should be compact. 0.77. What is the ratio of the Female students (as % of total students) of Brazil in 1977 to that in 2012?
Make the answer very short. 0.97. What is the ratio of the Female students (as % of total students) of Congo (Republic) in 1977 to that in 2012?
Keep it short and to the point. 0.98. What is the ratio of the Female students (as % of total students) in Norway in 1977 to that in 2012?
Offer a very short reply. 1.09. What is the ratio of the Female students (as % of total students) in Sub-Saharan Africa (all income levels) in 1978 to that in 2002?
Offer a terse response. 0.82. What is the ratio of the Female students (as % of total students) in Brazil in 1978 to that in 2002?
Your answer should be compact. 1.02. What is the ratio of the Female students (as % of total students) in Congo (Republic) in 1978 to that in 2002?
Your answer should be compact. 0.92. What is the ratio of the Female students (as % of total students) of Norway in 1978 to that in 2002?
Your answer should be very brief. 1.01. What is the ratio of the Female students (as % of total students) in Sub-Saharan Africa (all income levels) in 1978 to that in 2003?
Offer a very short reply. 0.81. What is the ratio of the Female students (as % of total students) of Brazil in 1978 to that in 2003?
Give a very brief answer. 0.75. What is the ratio of the Female students (as % of total students) in Congo (Republic) in 1978 to that in 2003?
Provide a short and direct response. 0.91. What is the ratio of the Female students (as % of total students) in Sub-Saharan Africa (all income levels) in 1978 to that in 2004?
Ensure brevity in your answer.  0.79. What is the ratio of the Female students (as % of total students) in Brazil in 1978 to that in 2004?
Your answer should be very brief. 1.16. What is the ratio of the Female students (as % of total students) in Norway in 1978 to that in 2004?
Keep it short and to the point. 0.99. What is the ratio of the Female students (as % of total students) of Sub-Saharan Africa (all income levels) in 1978 to that in 2012?
Keep it short and to the point. 0.77. What is the ratio of the Female students (as % of total students) of Brazil in 1978 to that in 2012?
Ensure brevity in your answer.  0.98. What is the ratio of the Female students (as % of total students) of Congo (Republic) in 1978 to that in 2012?
Offer a very short reply. 1.05. What is the ratio of the Female students (as % of total students) of Norway in 1978 to that in 2012?
Provide a succinct answer. 1.12. What is the ratio of the Female students (as % of total students) of Brazil in 2002 to that in 2003?
Make the answer very short. 0.74. What is the ratio of the Female students (as % of total students) of Sub-Saharan Africa (all income levels) in 2002 to that in 2004?
Make the answer very short. 0.97. What is the ratio of the Female students (as % of total students) of Brazil in 2002 to that in 2004?
Make the answer very short. 1.14. What is the ratio of the Female students (as % of total students) in Congo (Republic) in 2002 to that in 2004?
Your response must be concise. 1.09. What is the ratio of the Female students (as % of total students) in Norway in 2002 to that in 2004?
Your answer should be compact. 0.98. What is the ratio of the Female students (as % of total students) of Sub-Saharan Africa (all income levels) in 2002 to that in 2012?
Ensure brevity in your answer.  0.94. What is the ratio of the Female students (as % of total students) in Brazil in 2002 to that in 2012?
Provide a succinct answer. 0.97. What is the ratio of the Female students (as % of total students) in Congo (Republic) in 2002 to that in 2012?
Your answer should be compact. 1.15. What is the ratio of the Female students (as % of total students) in Norway in 2002 to that in 2012?
Your answer should be compact. 1.1. What is the ratio of the Female students (as % of total students) of Sub-Saharan Africa (all income levels) in 2003 to that in 2004?
Your answer should be compact. 0.98. What is the ratio of the Female students (as % of total students) in Brazil in 2003 to that in 2004?
Provide a short and direct response. 1.54. What is the ratio of the Female students (as % of total students) of Congo (Republic) in 2003 to that in 2004?
Your answer should be very brief. 1.1. What is the ratio of the Female students (as % of total students) of Norway in 2003 to that in 2004?
Keep it short and to the point. 0.99. What is the ratio of the Female students (as % of total students) of Sub-Saharan Africa (all income levels) in 2003 to that in 2012?
Provide a short and direct response. 0.95. What is the ratio of the Female students (as % of total students) in Brazil in 2003 to that in 2012?
Your answer should be very brief. 1.3. What is the ratio of the Female students (as % of total students) in Congo (Republic) in 2003 to that in 2012?
Provide a short and direct response. 1.16. What is the ratio of the Female students (as % of total students) of Norway in 2003 to that in 2012?
Keep it short and to the point. 1.11. What is the ratio of the Female students (as % of total students) of Sub-Saharan Africa (all income levels) in 2004 to that in 2012?
Give a very brief answer. 0.97. What is the ratio of the Female students (as % of total students) in Brazil in 2004 to that in 2012?
Give a very brief answer. 0.85. What is the ratio of the Female students (as % of total students) of Congo (Republic) in 2004 to that in 2012?
Provide a succinct answer. 1.05. What is the ratio of the Female students (as % of total students) in Norway in 2004 to that in 2012?
Offer a very short reply. 1.13. What is the difference between the highest and the second highest Female students (as % of total students) in Sub-Saharan Africa (all income levels)?
Your answer should be very brief. 1.12. What is the difference between the highest and the second highest Female students (as % of total students) in Brazil?
Keep it short and to the point. 16.96. What is the difference between the highest and the second highest Female students (as % of total students) in Congo (Republic)?
Your answer should be compact. 0.53. What is the difference between the highest and the second highest Female students (as % of total students) in Norway?
Your answer should be very brief. 0.43. What is the difference between the highest and the lowest Female students (as % of total students) in Sub-Saharan Africa (all income levels)?
Your response must be concise. 9.05. What is the difference between the highest and the lowest Female students (as % of total students) in Brazil?
Your answer should be very brief. 25.58. What is the difference between the highest and the lowest Female students (as % of total students) of Congo (Republic)?
Your answer should be very brief. 13.92. What is the difference between the highest and the lowest Female students (as % of total students) of Norway?
Provide a succinct answer. 5.14. 